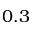Convert formula to latex. <formula><loc_0><loc_0><loc_500><loc_500>0 . 3</formula> 